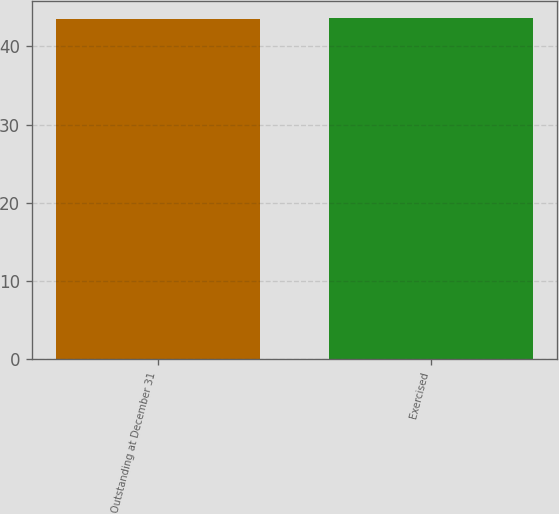Convert chart. <chart><loc_0><loc_0><loc_500><loc_500><bar_chart><fcel>Outstanding at December 31<fcel>Exercised<nl><fcel>43.5<fcel>43.6<nl></chart> 